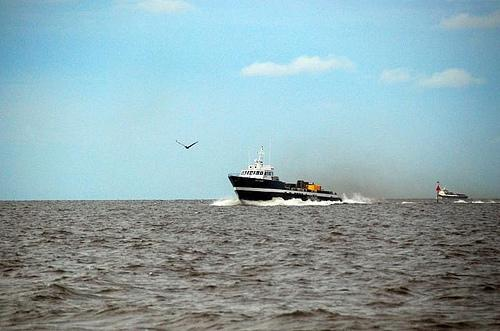What is the boat plowing through? water 